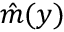Convert formula to latex. <formula><loc_0><loc_0><loc_500><loc_500>\hat { m } ( y )</formula> 